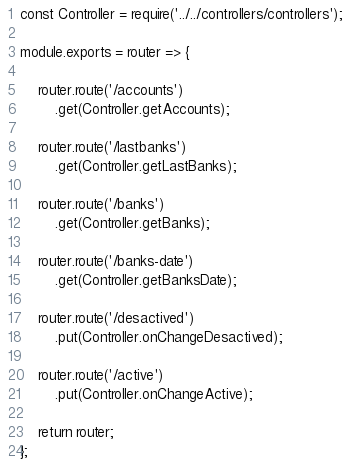<code> <loc_0><loc_0><loc_500><loc_500><_JavaScript_>const Controller = require('../../controllers/controllers');

module.exports = router => {

    router.route('/accounts')
        .get(Controller.getAccounts);

    router.route('/lastbanks')
        .get(Controller.getLastBanks);

    router.route('/banks')
        .get(Controller.getBanks);

    router.route('/banks-date')
        .get(Controller.getBanksDate);

    router.route('/desactived')
        .put(Controller.onChangeDesactived);

    router.route('/active')
        .put(Controller.onChangeActive);

    return router;
};
</code> 